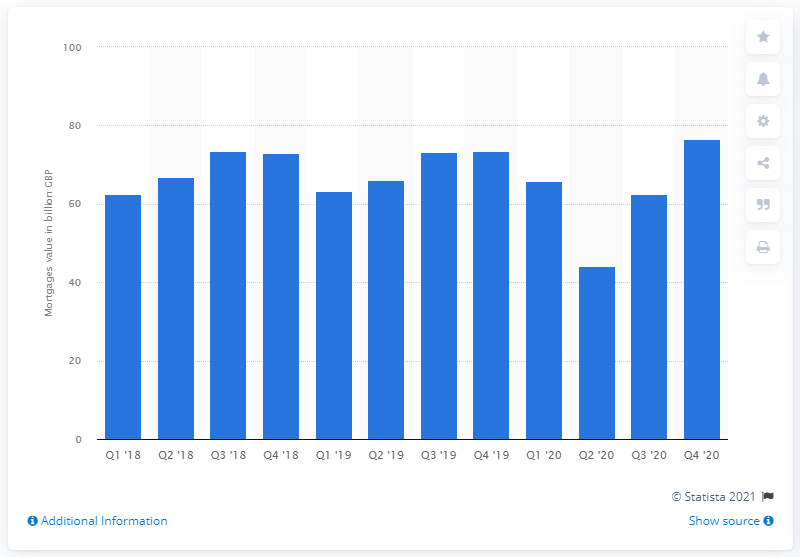Outline some significant characteristics in this image. In the second half of 2020, mortgage lending totaled 76.58. 